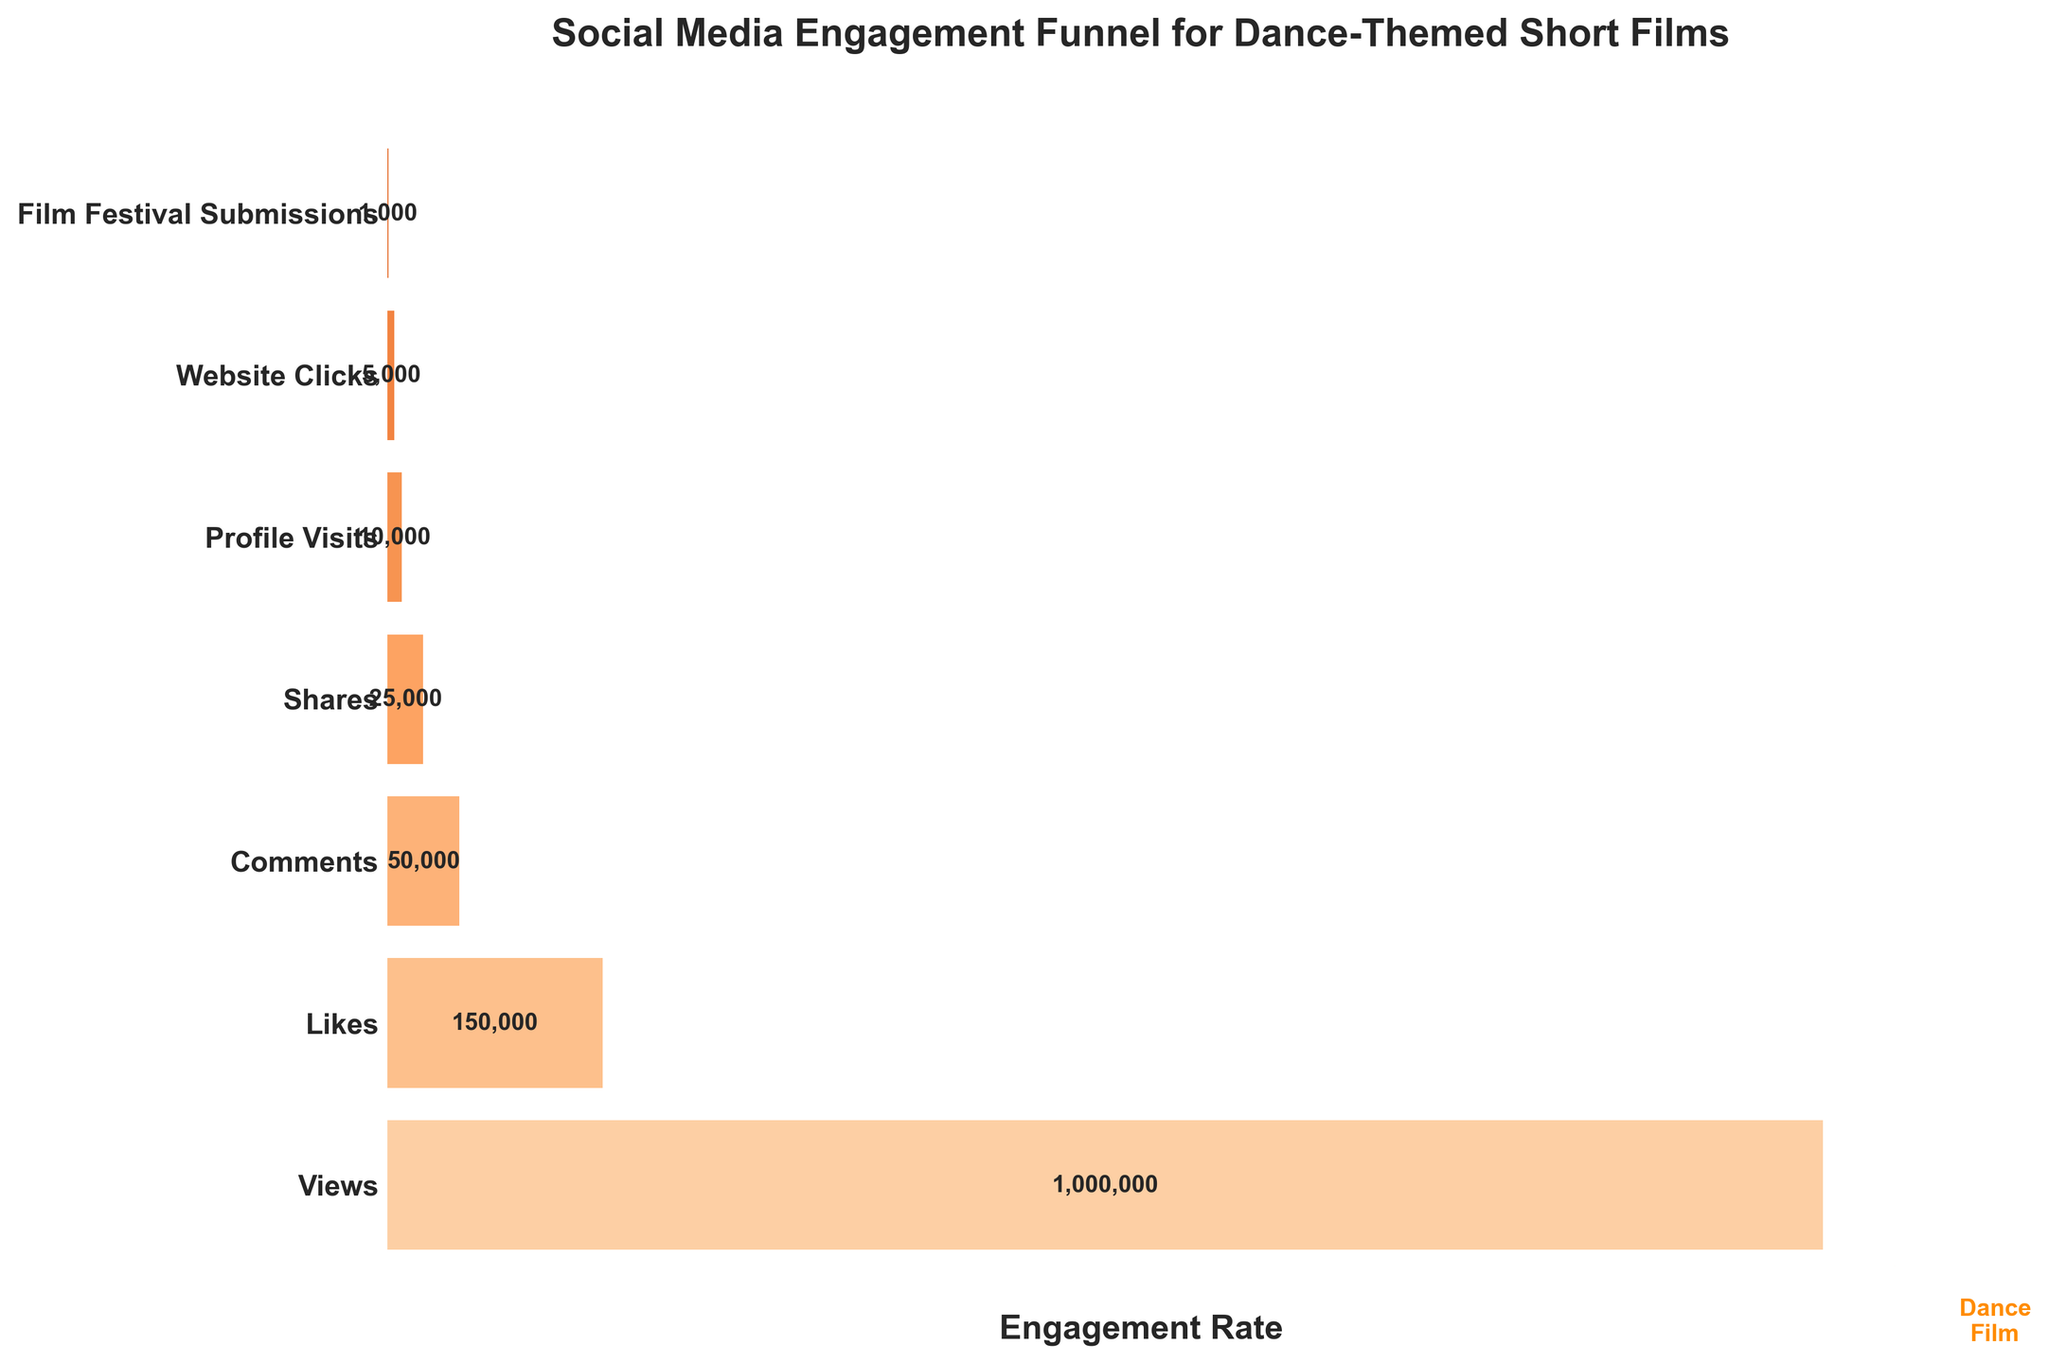Which stage of the funnel has the highest engagement? The stage with the highest engagement is the one with the largest bar (widest section) on the funnel chart. Based on the data, this is the "Views" stage.
Answer: Views How many profile visits are there? The number of profile visits can be directly read from the figure where the "Profile Visits" bar is labeled.
Answer: 10,000 What is the title of the chart? The title of the chart is the text displayed at the top of the figure. It is "Social Media Engagement Funnel for Dance-Themed Short Films."
Answer: Social Media Engagement Funnel for Dance-Themed Short Films Which stage has more engagement: Comments or Shares? To determine which stage has more engagement, compare the lengths of the "Comments" and "Shares" bars. The "Comments" bar is longer, indicating higher engagement.
Answer: Comments What is the difference in engagement between Likes and Film Festival Submissions? To find the difference, subtract the count for "Film Festival Submissions" from the count for "Likes". The counts are 150,000 and 1,000 respectively. So, 150,000 - 1,000 = 149,000.
Answer: 149,000 What is the order of stages from highest to lowest engagement? The order can be determined by reading the widths of the bars from the widest to narrowest. The order is: Views, Likes, Comments, Shares, Profile Visits, Website Clicks, Film Festival Submissions.
Answer: Views, Likes, Comments, Shares, Profile Visits, Website Clicks, Film Festival Submissions How many steps are there in this funnel? The number of steps corresponds to the number of distinct bars labeled from top to bottom.
Answer: 7 What percentage of views result in likes? To calculate the percentage, divide the number of likes by the number of views and multiply by 100. Using the data: (150,000 / 1,000,000) * 100 = 15%.
Answer: 15% Is the engagement for Website Clicks greater than Profile Visits? Compare the lengths of the bars for "Website Clicks" and "Profile Visits". The "Profile Visits" bar is longer, indicating greater engagement.
Answer: No What can you infer about the trend in engagement as we move down the funnel? The trend can be inferred by observing the widths of the bars. The bars become narrower as we move down the funnel, indicating decreasing engagement at each subsequent stage.
Answer: Engagement decreases 